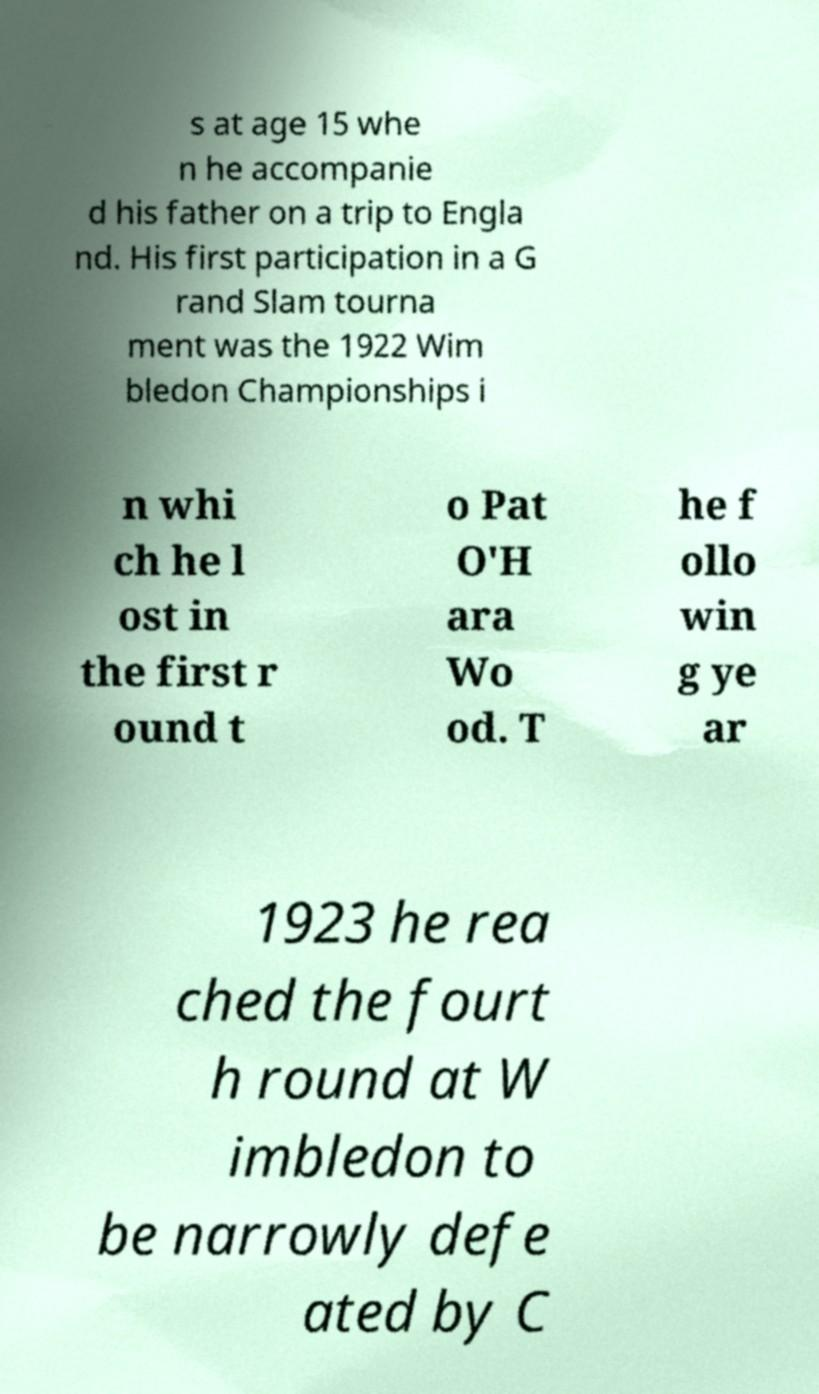Could you extract and type out the text from this image? s at age 15 whe n he accompanie d his father on a trip to Engla nd. His first participation in a G rand Slam tourna ment was the 1922 Wim bledon Championships i n whi ch he l ost in the first r ound t o Pat O'H ara Wo od. T he f ollo win g ye ar 1923 he rea ched the fourt h round at W imbledon to be narrowly defe ated by C 